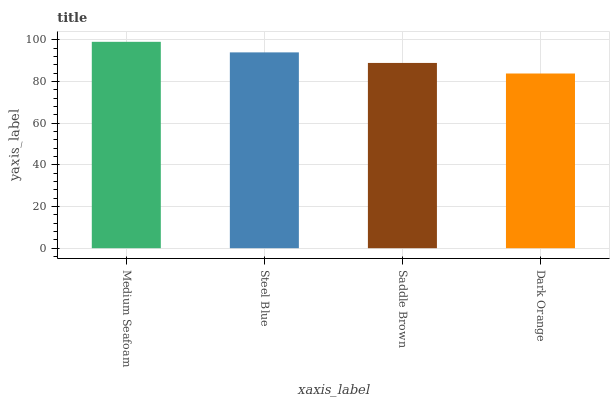Is Dark Orange the minimum?
Answer yes or no. Yes. Is Medium Seafoam the maximum?
Answer yes or no. Yes. Is Steel Blue the minimum?
Answer yes or no. No. Is Steel Blue the maximum?
Answer yes or no. No. Is Medium Seafoam greater than Steel Blue?
Answer yes or no. Yes. Is Steel Blue less than Medium Seafoam?
Answer yes or no. Yes. Is Steel Blue greater than Medium Seafoam?
Answer yes or no. No. Is Medium Seafoam less than Steel Blue?
Answer yes or no. No. Is Steel Blue the high median?
Answer yes or no. Yes. Is Saddle Brown the low median?
Answer yes or no. Yes. Is Dark Orange the high median?
Answer yes or no. No. Is Dark Orange the low median?
Answer yes or no. No. 